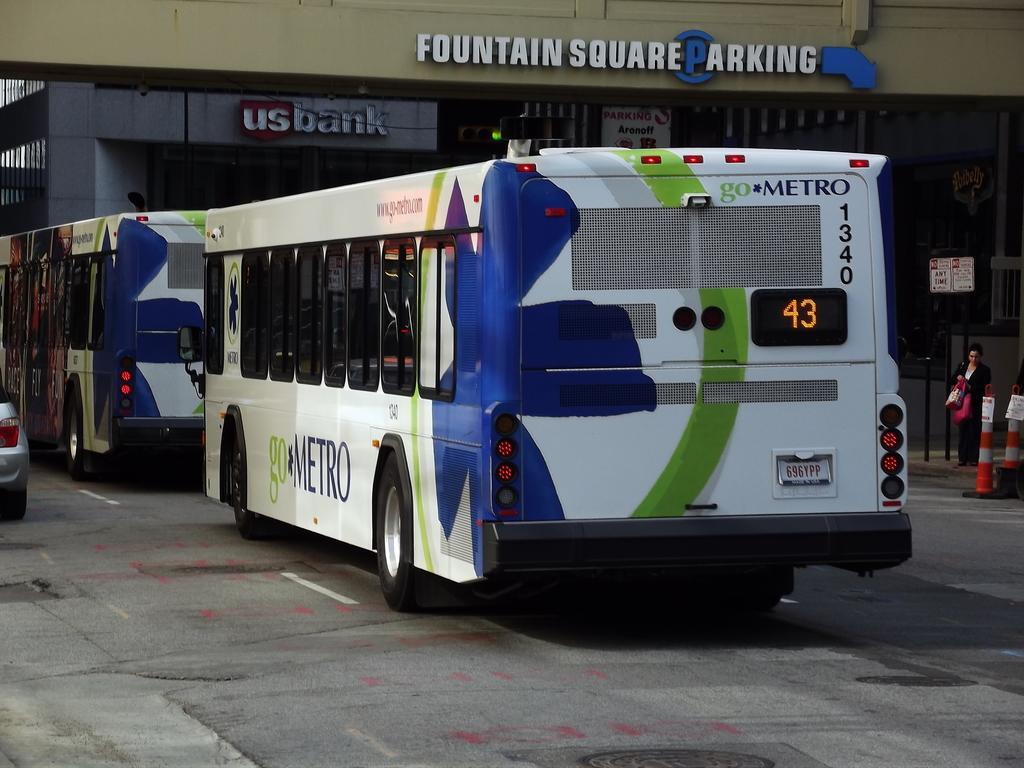Could you give a brief overview of what you see in this image? In this picture there are two buses on the road and there is fountain square parking written above it and there is a vehicle in the left corner and there is a woman standing in the right corner. 